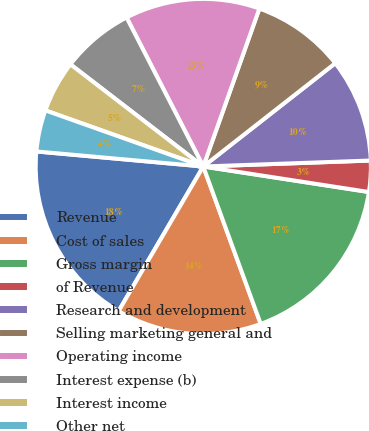<chart> <loc_0><loc_0><loc_500><loc_500><pie_chart><fcel>Revenue<fcel>Cost of sales<fcel>Gross margin<fcel>of Revenue<fcel>Research and development<fcel>Selling marketing general and<fcel>Operating income<fcel>Interest expense (b)<fcel>Interest income<fcel>Other net<nl><fcel>18.0%<fcel>14.0%<fcel>17.0%<fcel>3.0%<fcel>10.0%<fcel>9.0%<fcel>13.0%<fcel>7.0%<fcel>5.0%<fcel>4.0%<nl></chart> 